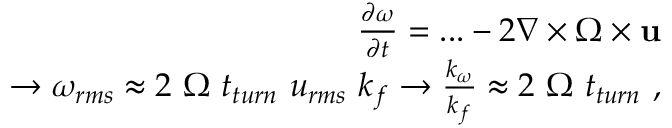<formula> <loc_0><loc_0><loc_500><loc_500>\begin{array} { r l r } & { \frac { \partial \omega } { \partial t } = \dots - 2 \nabla \times \Omega \times u } \\ & { \rightarrow \omega _ { r m s } \approx 2 \Omega t _ { t u r n } u _ { r m s } k _ { f } \rightarrow \frac { k _ { \omega } } { k _ { f } } \approx 2 \Omega t _ { t u r n } , } \end{array}</formula> 